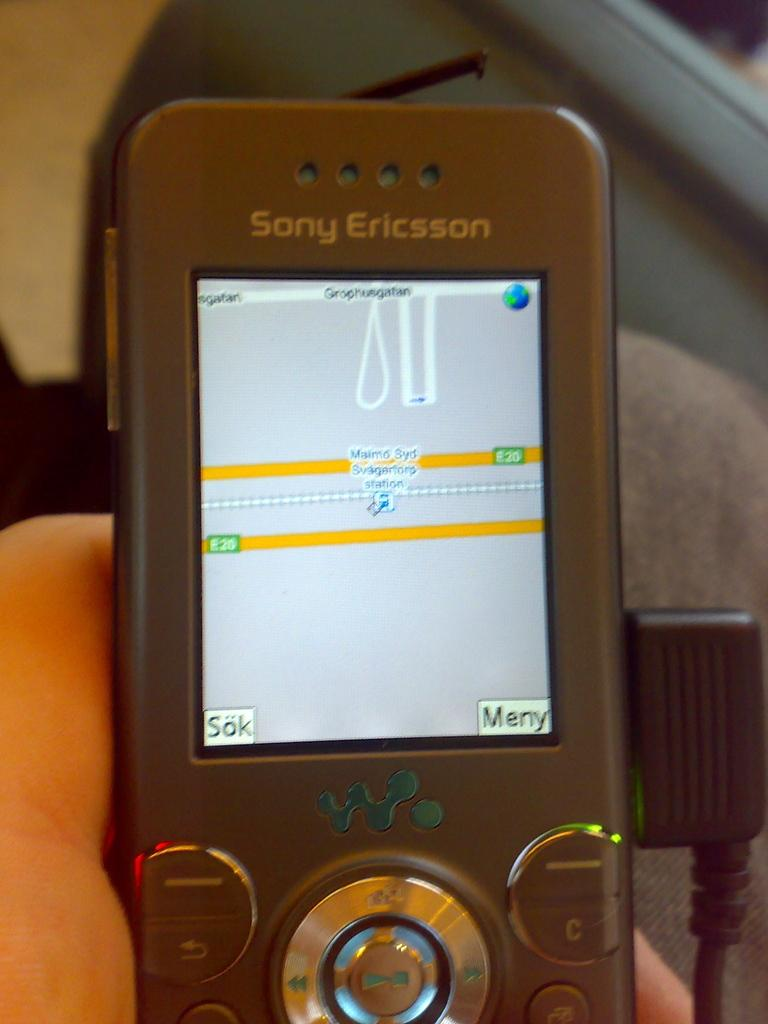Provide a one-sentence caption for the provided image. The map application is being used on a Sony Ericsson phone. 